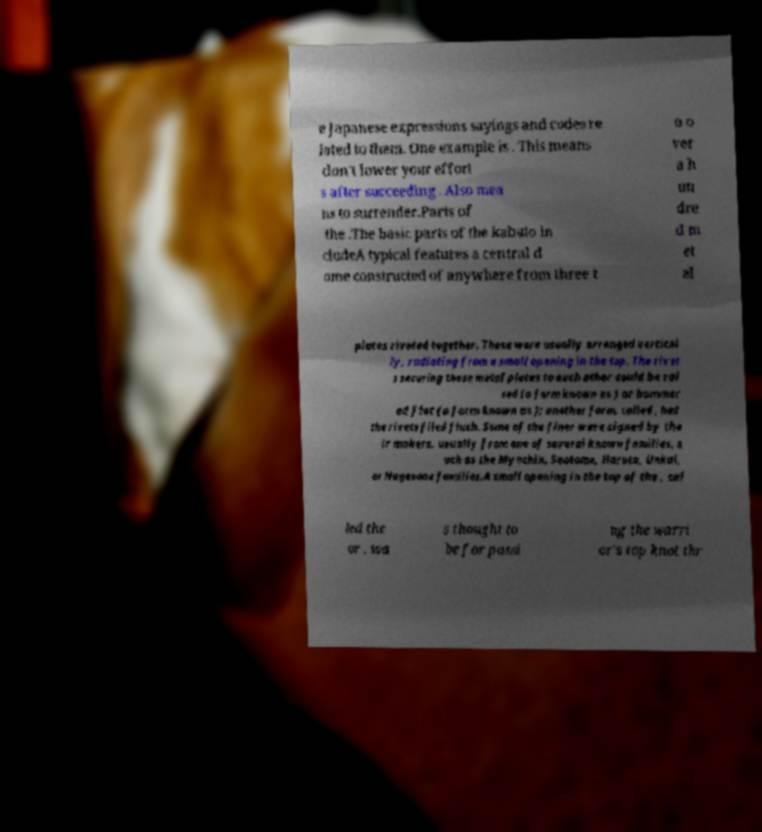Can you read and provide the text displayed in the image?This photo seems to have some interesting text. Can you extract and type it out for me? e Japanese expressions sayings and codes re lated to them. One example is . This means don't lower your effort s after succeeding . Also mea ns to surrender.Parts of the .The basic parts of the kabuto in cludeA typical features a central d ome constructed of anywhere from three t o o ver a h un dre d m et al plates riveted together. These were usually arranged vertical ly, radiating from a small opening in the top. The rivet s securing these metal plates to each other could be rai sed (a form known as ) or hammer ed flat (a form known as ); another form, called , had the rivets filed flush. Some of the finer were signed by the ir makers, usually from one of several known families, s uch as the Myochin, Saotome, Haruta, Unkai, or Nagasone families.A small opening in the top of the , cal led the or , wa s thought to be for passi ng the warri or's top knot thr 